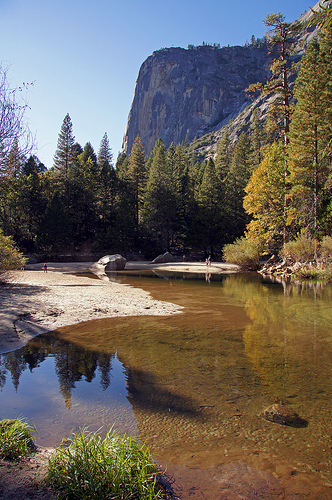<image>
Is the water in front of the mountain? Yes. The water is positioned in front of the mountain, appearing closer to the camera viewpoint. 